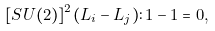Convert formula to latex. <formula><loc_0><loc_0><loc_500><loc_500>[ S U ( 2 ) ] ^ { 2 } ( L _ { i } - L _ { j } ) \colon 1 - 1 = 0 ,</formula> 